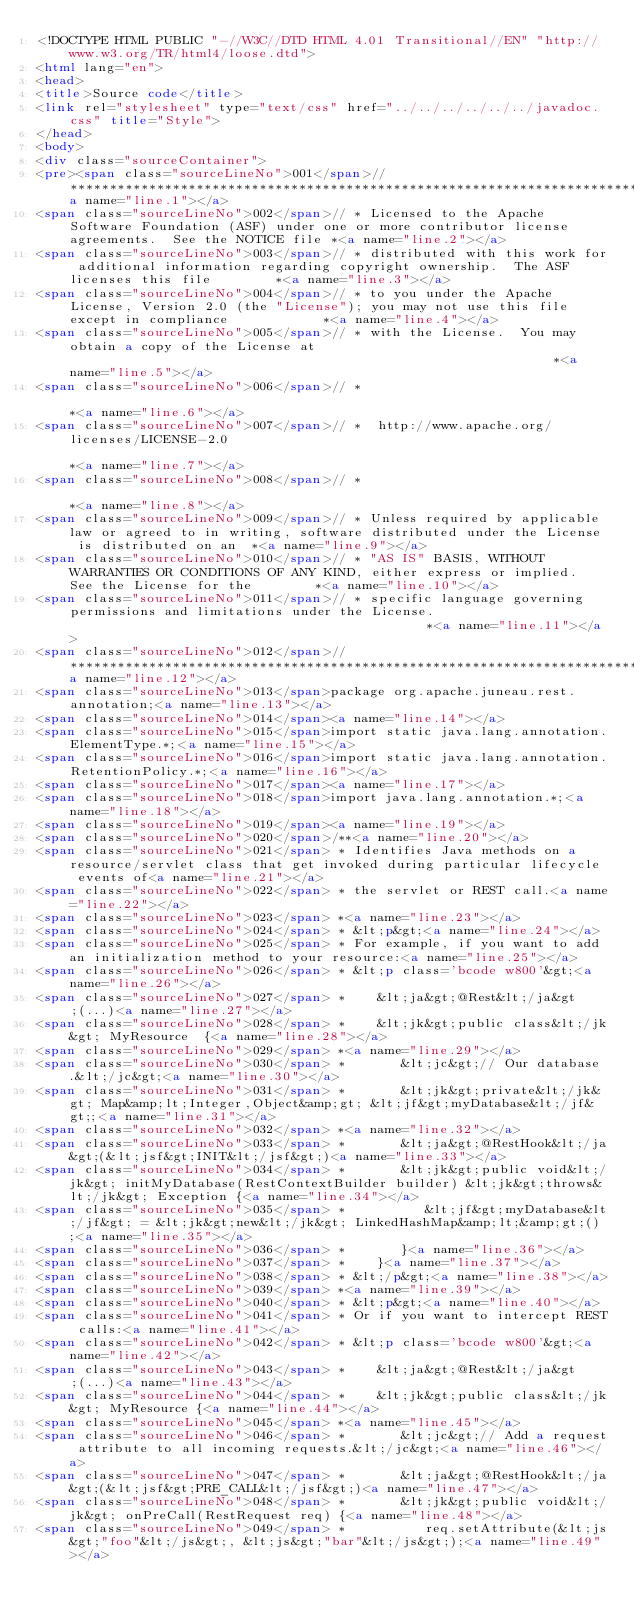<code> <loc_0><loc_0><loc_500><loc_500><_HTML_><!DOCTYPE HTML PUBLIC "-//W3C//DTD HTML 4.01 Transitional//EN" "http://www.w3.org/TR/html4/loose.dtd">
<html lang="en">
<head>
<title>Source code</title>
<link rel="stylesheet" type="text/css" href="../../../../../../javadoc.css" title="Style">
</head>
<body>
<div class="sourceContainer">
<pre><span class="sourceLineNo">001</span>// ***************************************************************************************************************************<a name="line.1"></a>
<span class="sourceLineNo">002</span>// * Licensed to the Apache Software Foundation (ASF) under one or more contributor license agreements.  See the NOTICE file *<a name="line.2"></a>
<span class="sourceLineNo">003</span>// * distributed with this work for additional information regarding copyright ownership.  The ASF licenses this file        *<a name="line.3"></a>
<span class="sourceLineNo">004</span>// * to you under the Apache License, Version 2.0 (the "License"); you may not use this file except in compliance            *<a name="line.4"></a>
<span class="sourceLineNo">005</span>// * with the License.  You may obtain a copy of the License at                                                              *<a name="line.5"></a>
<span class="sourceLineNo">006</span>// *                                                                                                                         *<a name="line.6"></a>
<span class="sourceLineNo">007</span>// *  http://www.apache.org/licenses/LICENSE-2.0                                                                             *<a name="line.7"></a>
<span class="sourceLineNo">008</span>// *                                                                                                                         *<a name="line.8"></a>
<span class="sourceLineNo">009</span>// * Unless required by applicable law or agreed to in writing, software distributed under the License is distributed on an  *<a name="line.9"></a>
<span class="sourceLineNo">010</span>// * "AS IS" BASIS, WITHOUT WARRANTIES OR CONDITIONS OF ANY KIND, either express or implied.  See the License for the        *<a name="line.10"></a>
<span class="sourceLineNo">011</span>// * specific language governing permissions and limitations under the License.                                              *<a name="line.11"></a>
<span class="sourceLineNo">012</span>// ***************************************************************************************************************************<a name="line.12"></a>
<span class="sourceLineNo">013</span>package org.apache.juneau.rest.annotation;<a name="line.13"></a>
<span class="sourceLineNo">014</span><a name="line.14"></a>
<span class="sourceLineNo">015</span>import static java.lang.annotation.ElementType.*;<a name="line.15"></a>
<span class="sourceLineNo">016</span>import static java.lang.annotation.RetentionPolicy.*;<a name="line.16"></a>
<span class="sourceLineNo">017</span><a name="line.17"></a>
<span class="sourceLineNo">018</span>import java.lang.annotation.*;<a name="line.18"></a>
<span class="sourceLineNo">019</span><a name="line.19"></a>
<span class="sourceLineNo">020</span>/**<a name="line.20"></a>
<span class="sourceLineNo">021</span> * Identifies Java methods on a resource/servlet class that get invoked during particular lifecycle events of<a name="line.21"></a>
<span class="sourceLineNo">022</span> * the servlet or REST call.<a name="line.22"></a>
<span class="sourceLineNo">023</span> *<a name="line.23"></a>
<span class="sourceLineNo">024</span> * &lt;p&gt;<a name="line.24"></a>
<span class="sourceLineNo">025</span> * For example, if you want to add an initialization method to your resource:<a name="line.25"></a>
<span class="sourceLineNo">026</span> * &lt;p class='bcode w800'&gt;<a name="line.26"></a>
<span class="sourceLineNo">027</span> *    &lt;ja&gt;@Rest&lt;/ja&gt;(...)<a name="line.27"></a>
<span class="sourceLineNo">028</span> *    &lt;jk&gt;public class&lt;/jk&gt; MyResource  {<a name="line.28"></a>
<span class="sourceLineNo">029</span> *<a name="line.29"></a>
<span class="sourceLineNo">030</span> *       &lt;jc&gt;// Our database.&lt;/jc&gt;<a name="line.30"></a>
<span class="sourceLineNo">031</span> *       &lt;jk&gt;private&lt;/jk&gt; Map&amp;lt;Integer,Object&amp;gt; &lt;jf&gt;myDatabase&lt;/jf&gt;;<a name="line.31"></a>
<span class="sourceLineNo">032</span> *<a name="line.32"></a>
<span class="sourceLineNo">033</span> *       &lt;ja&gt;@RestHook&lt;/ja&gt;(&lt;jsf&gt;INIT&lt;/jsf&gt;)<a name="line.33"></a>
<span class="sourceLineNo">034</span> *       &lt;jk&gt;public void&lt;/jk&gt; initMyDatabase(RestContextBuilder builder) &lt;jk&gt;throws&lt;/jk&gt; Exception {<a name="line.34"></a>
<span class="sourceLineNo">035</span> *          &lt;jf&gt;myDatabase&lt;/jf&gt; = &lt;jk&gt;new&lt;/jk&gt; LinkedHashMap&amp;lt;&amp;gt;();<a name="line.35"></a>
<span class="sourceLineNo">036</span> *       }<a name="line.36"></a>
<span class="sourceLineNo">037</span> *    }<a name="line.37"></a>
<span class="sourceLineNo">038</span> * &lt;/p&gt;<a name="line.38"></a>
<span class="sourceLineNo">039</span> *<a name="line.39"></a>
<span class="sourceLineNo">040</span> * &lt;p&gt;<a name="line.40"></a>
<span class="sourceLineNo">041</span> * Or if you want to intercept REST calls:<a name="line.41"></a>
<span class="sourceLineNo">042</span> * &lt;p class='bcode w800'&gt;<a name="line.42"></a>
<span class="sourceLineNo">043</span> *    &lt;ja&gt;@Rest&lt;/ja&gt;(...)<a name="line.43"></a>
<span class="sourceLineNo">044</span> *    &lt;jk&gt;public class&lt;/jk&gt; MyResource {<a name="line.44"></a>
<span class="sourceLineNo">045</span> *<a name="line.45"></a>
<span class="sourceLineNo">046</span> *       &lt;jc&gt;// Add a request attribute to all incoming requests.&lt;/jc&gt;<a name="line.46"></a>
<span class="sourceLineNo">047</span> *       &lt;ja&gt;@RestHook&lt;/ja&gt;(&lt;jsf&gt;PRE_CALL&lt;/jsf&gt;)<a name="line.47"></a>
<span class="sourceLineNo">048</span> *       &lt;jk&gt;public void&lt;/jk&gt; onPreCall(RestRequest req) {<a name="line.48"></a>
<span class="sourceLineNo">049</span> *          req.setAttribute(&lt;js&gt;"foo"&lt;/js&gt;, &lt;js&gt;"bar"&lt;/js&gt;);<a name="line.49"></a></code> 